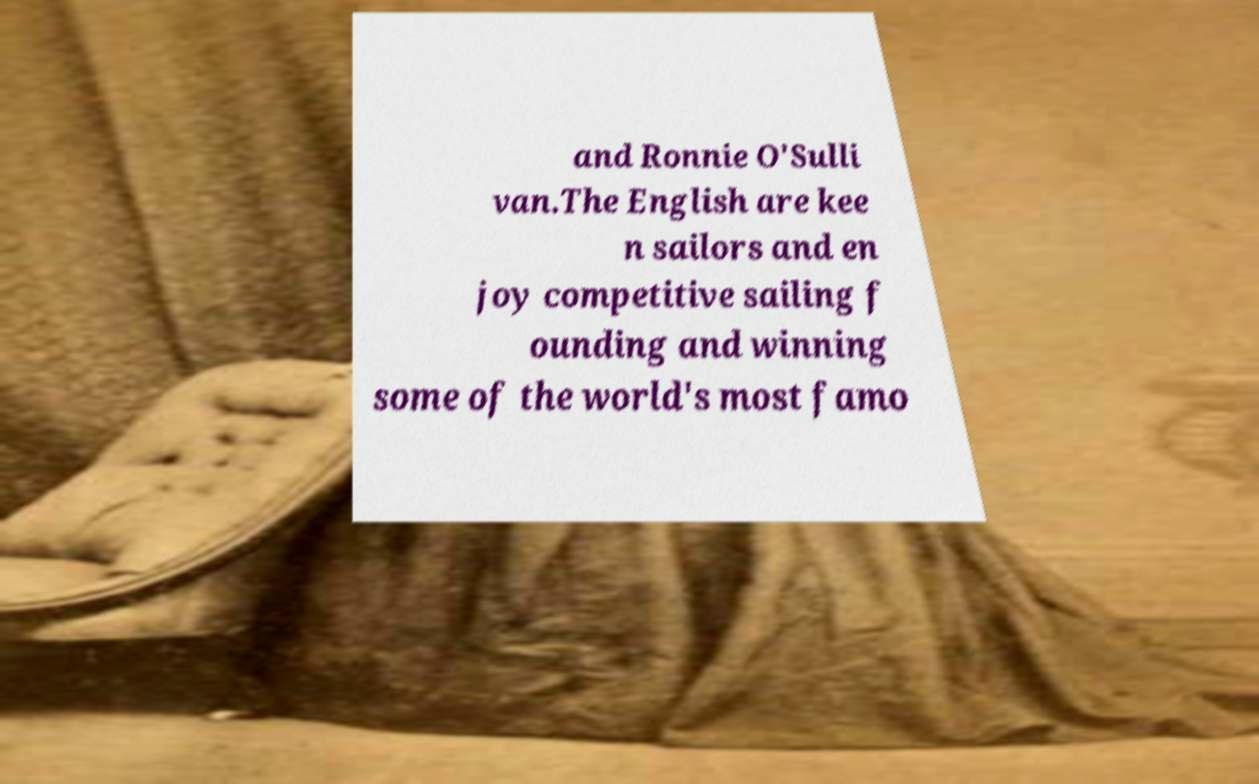Can you accurately transcribe the text from the provided image for me? and Ronnie O'Sulli van.The English are kee n sailors and en joy competitive sailing f ounding and winning some of the world's most famo 